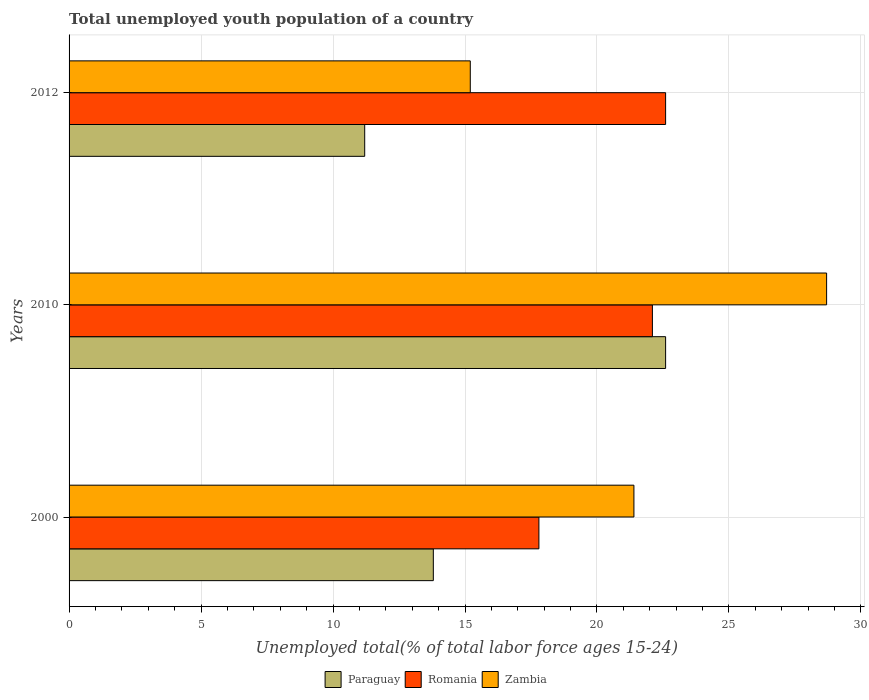How many different coloured bars are there?
Provide a succinct answer. 3. Are the number of bars per tick equal to the number of legend labels?
Offer a terse response. Yes. What is the label of the 3rd group of bars from the top?
Your response must be concise. 2000. What is the percentage of total unemployed youth population of a country in Romania in 2010?
Offer a terse response. 22.1. Across all years, what is the maximum percentage of total unemployed youth population of a country in Zambia?
Offer a terse response. 28.7. Across all years, what is the minimum percentage of total unemployed youth population of a country in Zambia?
Your answer should be very brief. 15.2. In which year was the percentage of total unemployed youth population of a country in Romania maximum?
Your answer should be very brief. 2012. In which year was the percentage of total unemployed youth population of a country in Zambia minimum?
Offer a terse response. 2012. What is the total percentage of total unemployed youth population of a country in Romania in the graph?
Your answer should be compact. 62.5. What is the difference between the percentage of total unemployed youth population of a country in Zambia in 2000 and that in 2010?
Provide a succinct answer. -7.3. What is the difference between the percentage of total unemployed youth population of a country in Paraguay in 2010 and the percentage of total unemployed youth population of a country in Romania in 2000?
Keep it short and to the point. 4.8. What is the average percentage of total unemployed youth population of a country in Zambia per year?
Provide a succinct answer. 21.77. In the year 2000, what is the difference between the percentage of total unemployed youth population of a country in Paraguay and percentage of total unemployed youth population of a country in Zambia?
Your answer should be very brief. -7.6. What is the ratio of the percentage of total unemployed youth population of a country in Zambia in 2000 to that in 2012?
Offer a terse response. 1.41. Is the difference between the percentage of total unemployed youth population of a country in Paraguay in 2010 and 2012 greater than the difference between the percentage of total unemployed youth population of a country in Zambia in 2010 and 2012?
Provide a succinct answer. No. What is the difference between the highest and the second highest percentage of total unemployed youth population of a country in Romania?
Your response must be concise. 0.5. What is the difference between the highest and the lowest percentage of total unemployed youth population of a country in Zambia?
Ensure brevity in your answer.  13.5. What does the 3rd bar from the top in 2010 represents?
Your answer should be compact. Paraguay. What does the 2nd bar from the bottom in 2012 represents?
Your answer should be very brief. Romania. How many bars are there?
Provide a succinct answer. 9. Are all the bars in the graph horizontal?
Make the answer very short. Yes. How many years are there in the graph?
Offer a very short reply. 3. What is the difference between two consecutive major ticks on the X-axis?
Provide a short and direct response. 5. Are the values on the major ticks of X-axis written in scientific E-notation?
Your answer should be very brief. No. Does the graph contain any zero values?
Your answer should be compact. No. Does the graph contain grids?
Your answer should be very brief. Yes. Where does the legend appear in the graph?
Provide a succinct answer. Bottom center. How many legend labels are there?
Your answer should be very brief. 3. What is the title of the graph?
Provide a succinct answer. Total unemployed youth population of a country. Does "Saudi Arabia" appear as one of the legend labels in the graph?
Offer a terse response. No. What is the label or title of the X-axis?
Your answer should be very brief. Unemployed total(% of total labor force ages 15-24). What is the label or title of the Y-axis?
Your answer should be compact. Years. What is the Unemployed total(% of total labor force ages 15-24) in Paraguay in 2000?
Your answer should be compact. 13.8. What is the Unemployed total(% of total labor force ages 15-24) of Romania in 2000?
Provide a short and direct response. 17.8. What is the Unemployed total(% of total labor force ages 15-24) of Zambia in 2000?
Make the answer very short. 21.4. What is the Unemployed total(% of total labor force ages 15-24) in Paraguay in 2010?
Your answer should be very brief. 22.6. What is the Unemployed total(% of total labor force ages 15-24) in Romania in 2010?
Provide a succinct answer. 22.1. What is the Unemployed total(% of total labor force ages 15-24) in Zambia in 2010?
Give a very brief answer. 28.7. What is the Unemployed total(% of total labor force ages 15-24) of Paraguay in 2012?
Your answer should be compact. 11.2. What is the Unemployed total(% of total labor force ages 15-24) of Romania in 2012?
Provide a succinct answer. 22.6. What is the Unemployed total(% of total labor force ages 15-24) of Zambia in 2012?
Provide a succinct answer. 15.2. Across all years, what is the maximum Unemployed total(% of total labor force ages 15-24) in Paraguay?
Give a very brief answer. 22.6. Across all years, what is the maximum Unemployed total(% of total labor force ages 15-24) of Romania?
Offer a very short reply. 22.6. Across all years, what is the maximum Unemployed total(% of total labor force ages 15-24) of Zambia?
Give a very brief answer. 28.7. Across all years, what is the minimum Unemployed total(% of total labor force ages 15-24) of Paraguay?
Make the answer very short. 11.2. Across all years, what is the minimum Unemployed total(% of total labor force ages 15-24) in Romania?
Provide a short and direct response. 17.8. Across all years, what is the minimum Unemployed total(% of total labor force ages 15-24) in Zambia?
Make the answer very short. 15.2. What is the total Unemployed total(% of total labor force ages 15-24) of Paraguay in the graph?
Make the answer very short. 47.6. What is the total Unemployed total(% of total labor force ages 15-24) of Romania in the graph?
Provide a short and direct response. 62.5. What is the total Unemployed total(% of total labor force ages 15-24) of Zambia in the graph?
Offer a terse response. 65.3. What is the difference between the Unemployed total(% of total labor force ages 15-24) in Romania in 2000 and that in 2010?
Your response must be concise. -4.3. What is the difference between the Unemployed total(% of total labor force ages 15-24) of Zambia in 2000 and that in 2010?
Offer a terse response. -7.3. What is the difference between the Unemployed total(% of total labor force ages 15-24) in Paraguay in 2000 and that in 2012?
Make the answer very short. 2.6. What is the difference between the Unemployed total(% of total labor force ages 15-24) of Romania in 2010 and that in 2012?
Your response must be concise. -0.5. What is the difference between the Unemployed total(% of total labor force ages 15-24) in Paraguay in 2000 and the Unemployed total(% of total labor force ages 15-24) in Romania in 2010?
Give a very brief answer. -8.3. What is the difference between the Unemployed total(% of total labor force ages 15-24) of Paraguay in 2000 and the Unemployed total(% of total labor force ages 15-24) of Zambia in 2010?
Provide a succinct answer. -14.9. What is the difference between the Unemployed total(% of total labor force ages 15-24) in Romania in 2000 and the Unemployed total(% of total labor force ages 15-24) in Zambia in 2010?
Your response must be concise. -10.9. What is the difference between the Unemployed total(% of total labor force ages 15-24) in Paraguay in 2000 and the Unemployed total(% of total labor force ages 15-24) in Romania in 2012?
Provide a succinct answer. -8.8. What is the difference between the Unemployed total(% of total labor force ages 15-24) of Paraguay in 2010 and the Unemployed total(% of total labor force ages 15-24) of Romania in 2012?
Provide a short and direct response. 0. What is the difference between the Unemployed total(% of total labor force ages 15-24) in Romania in 2010 and the Unemployed total(% of total labor force ages 15-24) in Zambia in 2012?
Make the answer very short. 6.9. What is the average Unemployed total(% of total labor force ages 15-24) in Paraguay per year?
Offer a very short reply. 15.87. What is the average Unemployed total(% of total labor force ages 15-24) of Romania per year?
Offer a terse response. 20.83. What is the average Unemployed total(% of total labor force ages 15-24) of Zambia per year?
Your answer should be very brief. 21.77. In the year 2000, what is the difference between the Unemployed total(% of total labor force ages 15-24) in Paraguay and Unemployed total(% of total labor force ages 15-24) in Zambia?
Provide a short and direct response. -7.6. In the year 2000, what is the difference between the Unemployed total(% of total labor force ages 15-24) in Romania and Unemployed total(% of total labor force ages 15-24) in Zambia?
Your answer should be compact. -3.6. In the year 2010, what is the difference between the Unemployed total(% of total labor force ages 15-24) in Romania and Unemployed total(% of total labor force ages 15-24) in Zambia?
Provide a short and direct response. -6.6. In the year 2012, what is the difference between the Unemployed total(% of total labor force ages 15-24) in Paraguay and Unemployed total(% of total labor force ages 15-24) in Romania?
Make the answer very short. -11.4. In the year 2012, what is the difference between the Unemployed total(% of total labor force ages 15-24) in Romania and Unemployed total(% of total labor force ages 15-24) in Zambia?
Keep it short and to the point. 7.4. What is the ratio of the Unemployed total(% of total labor force ages 15-24) of Paraguay in 2000 to that in 2010?
Give a very brief answer. 0.61. What is the ratio of the Unemployed total(% of total labor force ages 15-24) of Romania in 2000 to that in 2010?
Provide a succinct answer. 0.81. What is the ratio of the Unemployed total(% of total labor force ages 15-24) in Zambia in 2000 to that in 2010?
Your response must be concise. 0.75. What is the ratio of the Unemployed total(% of total labor force ages 15-24) in Paraguay in 2000 to that in 2012?
Keep it short and to the point. 1.23. What is the ratio of the Unemployed total(% of total labor force ages 15-24) of Romania in 2000 to that in 2012?
Provide a short and direct response. 0.79. What is the ratio of the Unemployed total(% of total labor force ages 15-24) of Zambia in 2000 to that in 2012?
Ensure brevity in your answer.  1.41. What is the ratio of the Unemployed total(% of total labor force ages 15-24) of Paraguay in 2010 to that in 2012?
Offer a terse response. 2.02. What is the ratio of the Unemployed total(% of total labor force ages 15-24) of Romania in 2010 to that in 2012?
Make the answer very short. 0.98. What is the ratio of the Unemployed total(% of total labor force ages 15-24) in Zambia in 2010 to that in 2012?
Give a very brief answer. 1.89. What is the difference between the highest and the second highest Unemployed total(% of total labor force ages 15-24) of Paraguay?
Offer a terse response. 8.8. What is the difference between the highest and the second highest Unemployed total(% of total labor force ages 15-24) of Romania?
Your response must be concise. 0.5. What is the difference between the highest and the second highest Unemployed total(% of total labor force ages 15-24) in Zambia?
Give a very brief answer. 7.3. What is the difference between the highest and the lowest Unemployed total(% of total labor force ages 15-24) in Paraguay?
Provide a short and direct response. 11.4. 